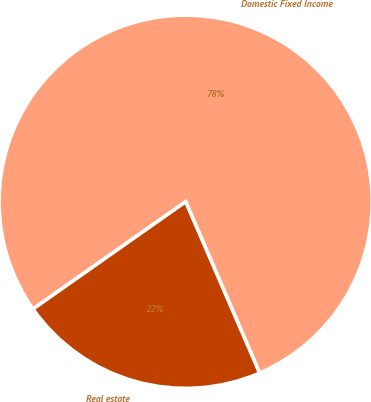Convert chart to OTSL. <chart><loc_0><loc_0><loc_500><loc_500><pie_chart><fcel>Domestic Fixed Income<fcel>Real estate<nl><fcel>78.26%<fcel>21.74%<nl></chart> 